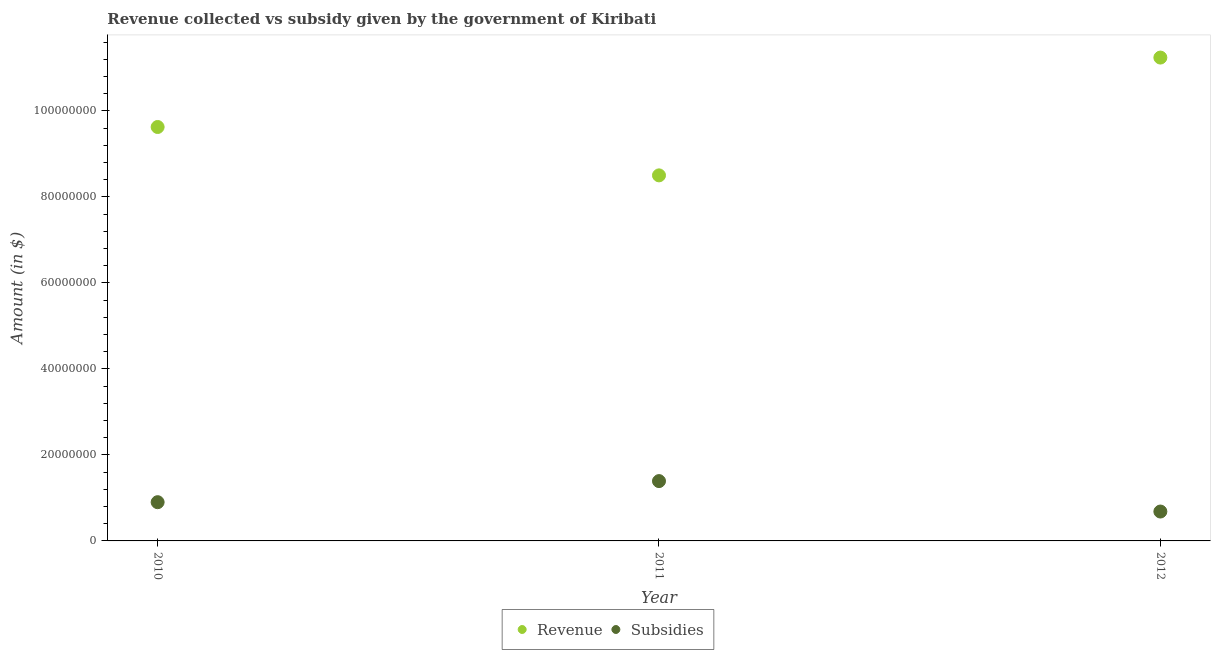Is the number of dotlines equal to the number of legend labels?
Offer a very short reply. Yes. What is the amount of revenue collected in 2012?
Ensure brevity in your answer.  1.12e+08. Across all years, what is the maximum amount of subsidies given?
Make the answer very short. 1.39e+07. Across all years, what is the minimum amount of revenue collected?
Give a very brief answer. 8.50e+07. In which year was the amount of revenue collected maximum?
Provide a succinct answer. 2012. What is the total amount of revenue collected in the graph?
Provide a succinct answer. 2.94e+08. What is the difference between the amount of revenue collected in 2011 and that in 2012?
Provide a short and direct response. -2.74e+07. What is the difference between the amount of revenue collected in 2010 and the amount of subsidies given in 2012?
Offer a terse response. 8.94e+07. What is the average amount of subsidies given per year?
Offer a very short reply. 9.92e+06. In the year 2011, what is the difference between the amount of revenue collected and amount of subsidies given?
Your answer should be compact. 7.11e+07. In how many years, is the amount of revenue collected greater than 40000000 $?
Ensure brevity in your answer.  3. What is the ratio of the amount of revenue collected in 2011 to that in 2012?
Give a very brief answer. 0.76. Is the amount of subsidies given in 2010 less than that in 2011?
Your answer should be very brief. Yes. What is the difference between the highest and the second highest amount of subsidies given?
Provide a short and direct response. 4.91e+06. What is the difference between the highest and the lowest amount of subsidies given?
Your answer should be very brief. 7.08e+06. Is the sum of the amount of revenue collected in 2010 and 2011 greater than the maximum amount of subsidies given across all years?
Offer a terse response. Yes. Does the amount of revenue collected monotonically increase over the years?
Provide a short and direct response. No. How many dotlines are there?
Your answer should be very brief. 2. What is the difference between two consecutive major ticks on the Y-axis?
Offer a very short reply. 2.00e+07. Are the values on the major ticks of Y-axis written in scientific E-notation?
Provide a short and direct response. No. Where does the legend appear in the graph?
Ensure brevity in your answer.  Bottom center. How many legend labels are there?
Offer a terse response. 2. How are the legend labels stacked?
Your answer should be compact. Horizontal. What is the title of the graph?
Ensure brevity in your answer.  Revenue collected vs subsidy given by the government of Kiribati. What is the label or title of the X-axis?
Your answer should be very brief. Year. What is the label or title of the Y-axis?
Your answer should be compact. Amount (in $). What is the Amount (in $) of Revenue in 2010?
Your response must be concise. 9.63e+07. What is the Amount (in $) of Subsidies in 2010?
Provide a succinct answer. 9.01e+06. What is the Amount (in $) of Revenue in 2011?
Make the answer very short. 8.50e+07. What is the Amount (in $) in Subsidies in 2011?
Your response must be concise. 1.39e+07. What is the Amount (in $) of Revenue in 2012?
Your answer should be very brief. 1.12e+08. What is the Amount (in $) of Subsidies in 2012?
Your answer should be very brief. 6.83e+06. Across all years, what is the maximum Amount (in $) in Revenue?
Keep it short and to the point. 1.12e+08. Across all years, what is the maximum Amount (in $) of Subsidies?
Keep it short and to the point. 1.39e+07. Across all years, what is the minimum Amount (in $) of Revenue?
Give a very brief answer. 8.50e+07. Across all years, what is the minimum Amount (in $) of Subsidies?
Make the answer very short. 6.83e+06. What is the total Amount (in $) in Revenue in the graph?
Your response must be concise. 2.94e+08. What is the total Amount (in $) of Subsidies in the graph?
Provide a succinct answer. 2.98e+07. What is the difference between the Amount (in $) of Revenue in 2010 and that in 2011?
Make the answer very short. 1.13e+07. What is the difference between the Amount (in $) in Subsidies in 2010 and that in 2011?
Offer a very short reply. -4.91e+06. What is the difference between the Amount (in $) of Revenue in 2010 and that in 2012?
Your answer should be very brief. -1.61e+07. What is the difference between the Amount (in $) of Subsidies in 2010 and that in 2012?
Your answer should be compact. 2.17e+06. What is the difference between the Amount (in $) in Revenue in 2011 and that in 2012?
Your response must be concise. -2.74e+07. What is the difference between the Amount (in $) in Subsidies in 2011 and that in 2012?
Make the answer very short. 7.08e+06. What is the difference between the Amount (in $) in Revenue in 2010 and the Amount (in $) in Subsidies in 2011?
Provide a succinct answer. 8.24e+07. What is the difference between the Amount (in $) in Revenue in 2010 and the Amount (in $) in Subsidies in 2012?
Provide a short and direct response. 8.94e+07. What is the difference between the Amount (in $) in Revenue in 2011 and the Amount (in $) in Subsidies in 2012?
Your answer should be compact. 7.82e+07. What is the average Amount (in $) of Revenue per year?
Provide a succinct answer. 9.79e+07. What is the average Amount (in $) in Subsidies per year?
Provide a succinct answer. 9.92e+06. In the year 2010, what is the difference between the Amount (in $) of Revenue and Amount (in $) of Subsidies?
Your response must be concise. 8.73e+07. In the year 2011, what is the difference between the Amount (in $) in Revenue and Amount (in $) in Subsidies?
Your answer should be very brief. 7.11e+07. In the year 2012, what is the difference between the Amount (in $) in Revenue and Amount (in $) in Subsidies?
Your answer should be very brief. 1.06e+08. What is the ratio of the Amount (in $) of Revenue in 2010 to that in 2011?
Provide a succinct answer. 1.13. What is the ratio of the Amount (in $) in Subsidies in 2010 to that in 2011?
Provide a succinct answer. 0.65. What is the ratio of the Amount (in $) of Revenue in 2010 to that in 2012?
Offer a terse response. 0.86. What is the ratio of the Amount (in $) in Subsidies in 2010 to that in 2012?
Ensure brevity in your answer.  1.32. What is the ratio of the Amount (in $) in Revenue in 2011 to that in 2012?
Offer a very short reply. 0.76. What is the ratio of the Amount (in $) in Subsidies in 2011 to that in 2012?
Provide a short and direct response. 2.04. What is the difference between the highest and the second highest Amount (in $) in Revenue?
Give a very brief answer. 1.61e+07. What is the difference between the highest and the second highest Amount (in $) of Subsidies?
Your response must be concise. 4.91e+06. What is the difference between the highest and the lowest Amount (in $) in Revenue?
Make the answer very short. 2.74e+07. What is the difference between the highest and the lowest Amount (in $) of Subsidies?
Ensure brevity in your answer.  7.08e+06. 